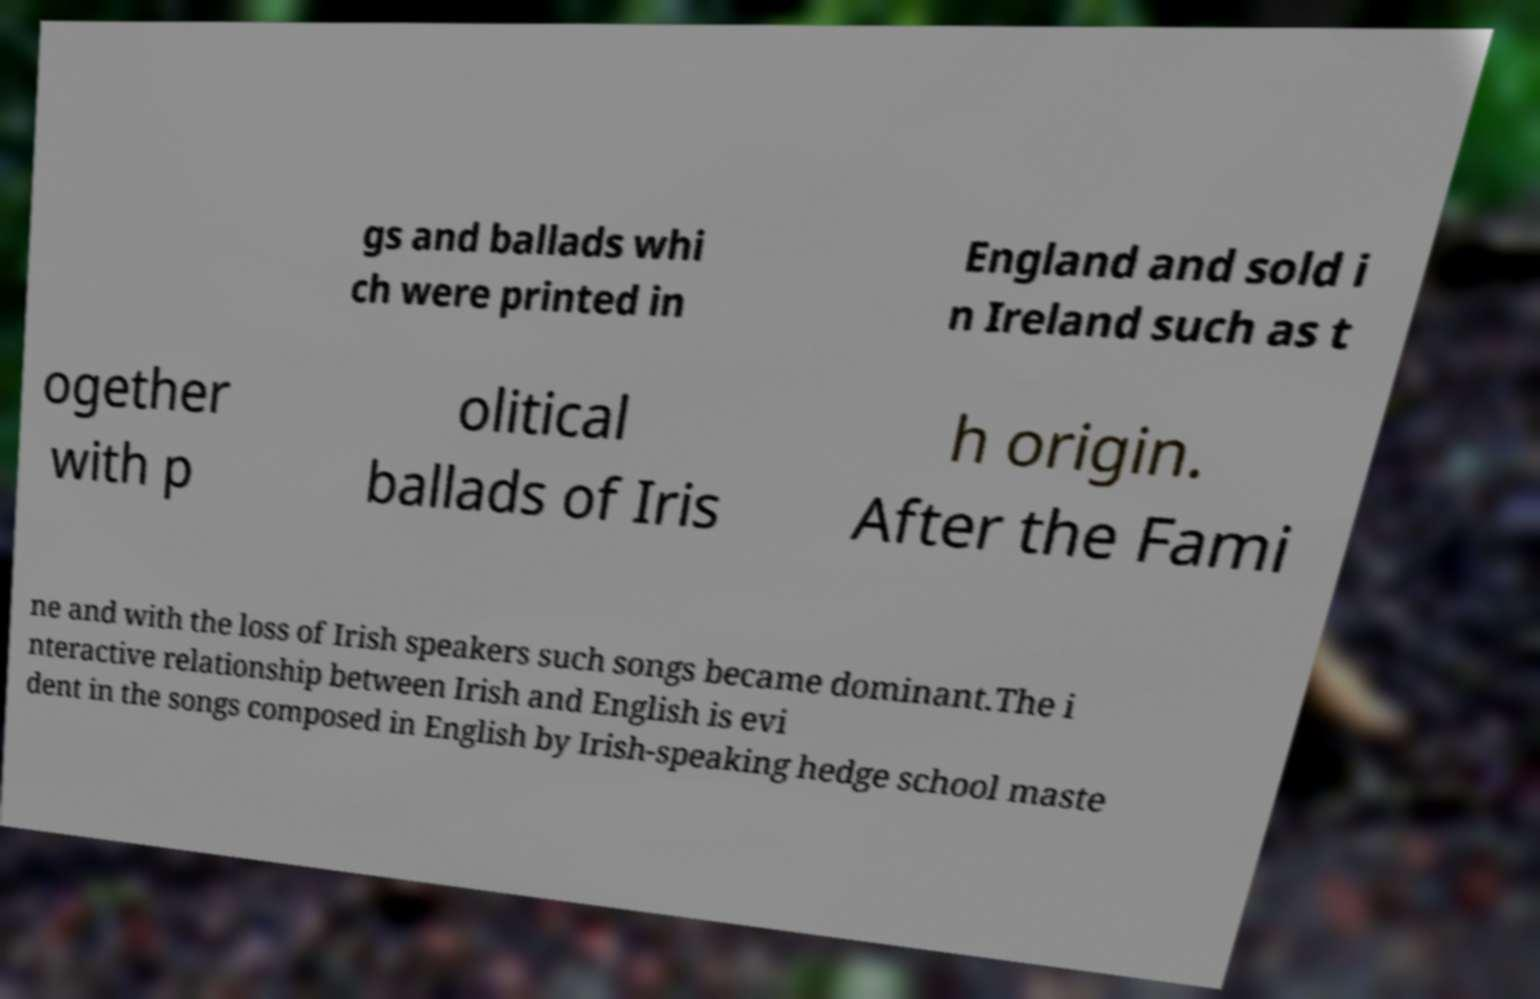I need the written content from this picture converted into text. Can you do that? gs and ballads whi ch were printed in England and sold i n Ireland such as t ogether with p olitical ballads of Iris h origin. After the Fami ne and with the loss of Irish speakers such songs became dominant.The i nteractive relationship between Irish and English is evi dent in the songs composed in English by Irish-speaking hedge school maste 